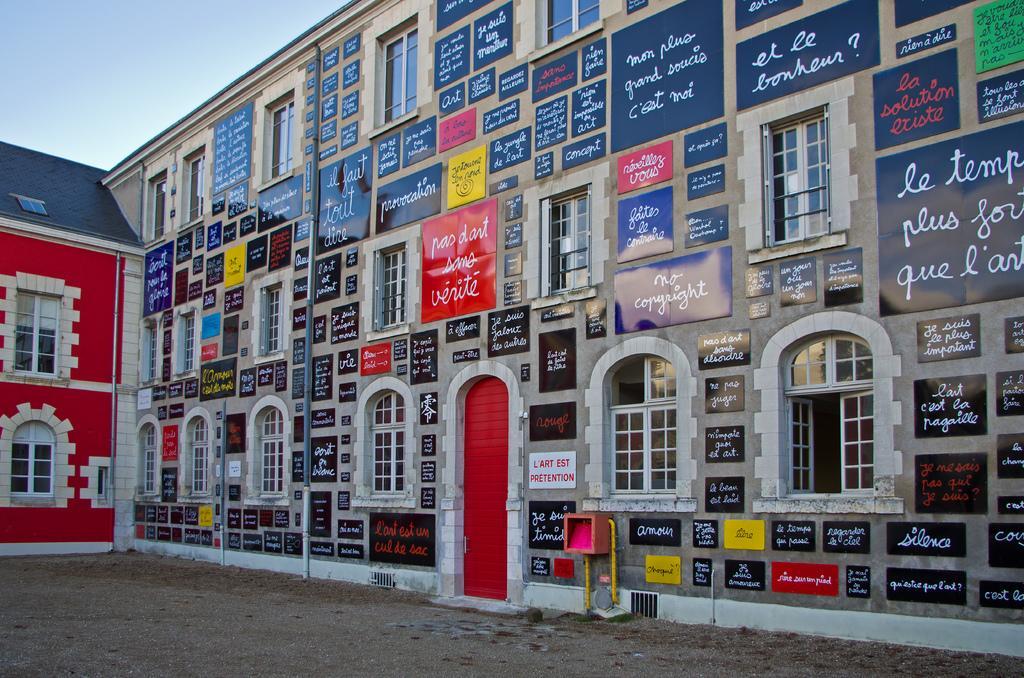In one or two sentences, can you explain what this image depicts? In this image we can see many boards to the wall on which we can see some text is written, here we can see the pipes, windows, red color door, ground, red color wall and the pale blue color sky in the background. 